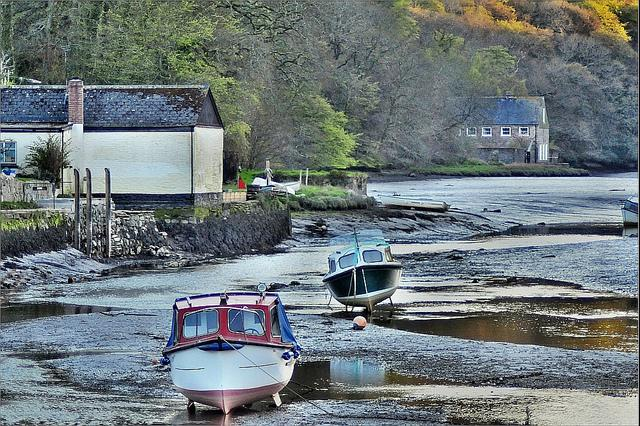What shape is the item on the floor that is in front of the boat that is behind the red boat? round 